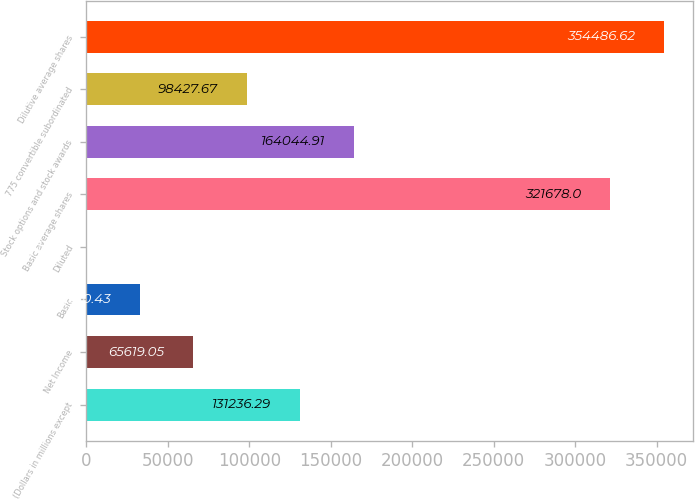Convert chart. <chart><loc_0><loc_0><loc_500><loc_500><bar_chart><fcel>(Dollars in millions except<fcel>Net Income<fcel>Basic<fcel>Diluted<fcel>Basic average shares<fcel>Stock options and stock awards<fcel>775 convertible subordinated<fcel>Dilutive average shares<nl><fcel>131236<fcel>65619.1<fcel>32810.4<fcel>1.81<fcel>321678<fcel>164045<fcel>98427.7<fcel>354487<nl></chart> 